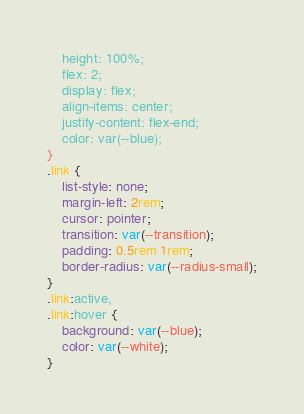<code> <loc_0><loc_0><loc_500><loc_500><_CSS_>	height: 100%;
	flex: 2;
	display: flex;
	align-items: center;
	justify-content: flex-end;
	color: var(--blue);
}
.link {
	list-style: none;
	margin-left: 2rem;
	cursor: pointer;
	transition: var(--transition);
	padding: 0.5rem 1rem;
	border-radius: var(--radius-small);
}
.link:active,
.link:hover {
	background: var(--blue);
	color: var(--white);
}
</code> 